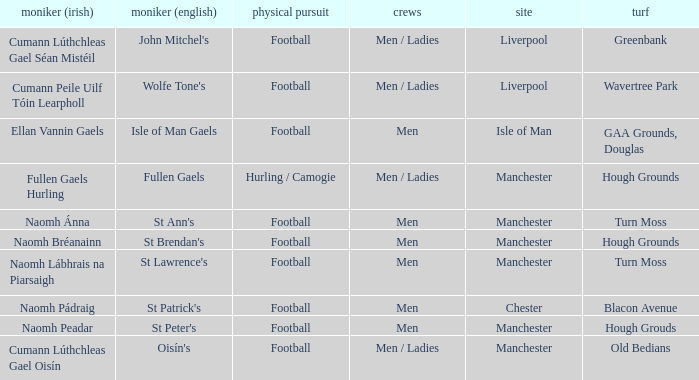What Pitch is located at Isle of Man? GAA Grounds, Douglas. 